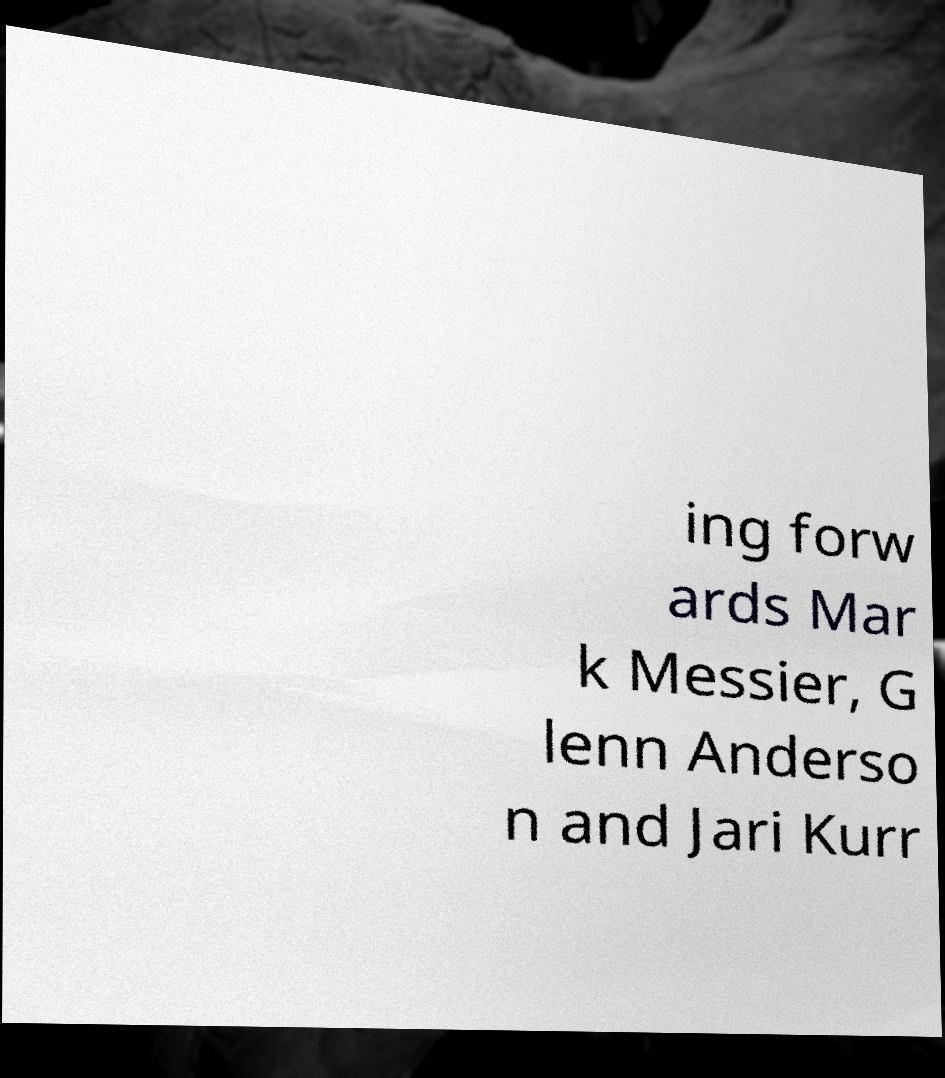I need the written content from this picture converted into text. Can you do that? ing forw ards Mar k Messier, G lenn Anderso n and Jari Kurr 